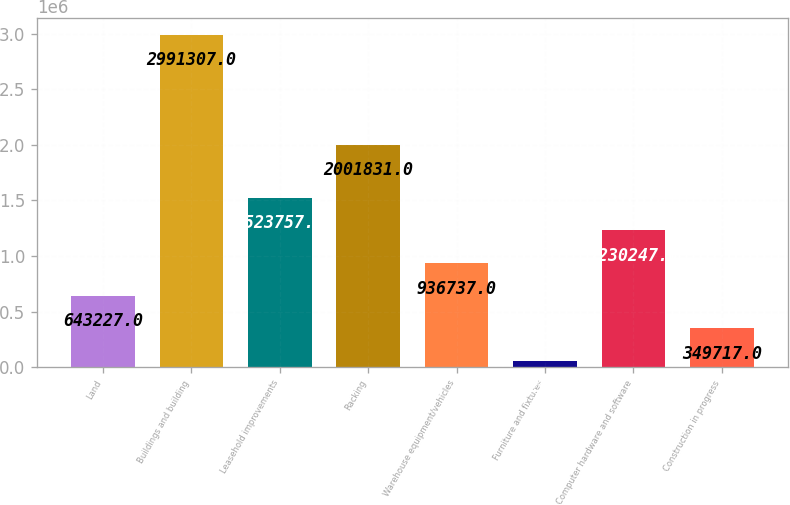Convert chart. <chart><loc_0><loc_0><loc_500><loc_500><bar_chart><fcel>Land<fcel>Buildings and building<fcel>Leasehold improvements<fcel>Racking<fcel>Warehouse equipment/vehicles<fcel>Furniture and fixtures<fcel>Computer hardware and software<fcel>Construction in progress<nl><fcel>643227<fcel>2.99131e+06<fcel>1.52376e+06<fcel>2.00183e+06<fcel>936737<fcel>56207<fcel>1.23025e+06<fcel>349717<nl></chart> 